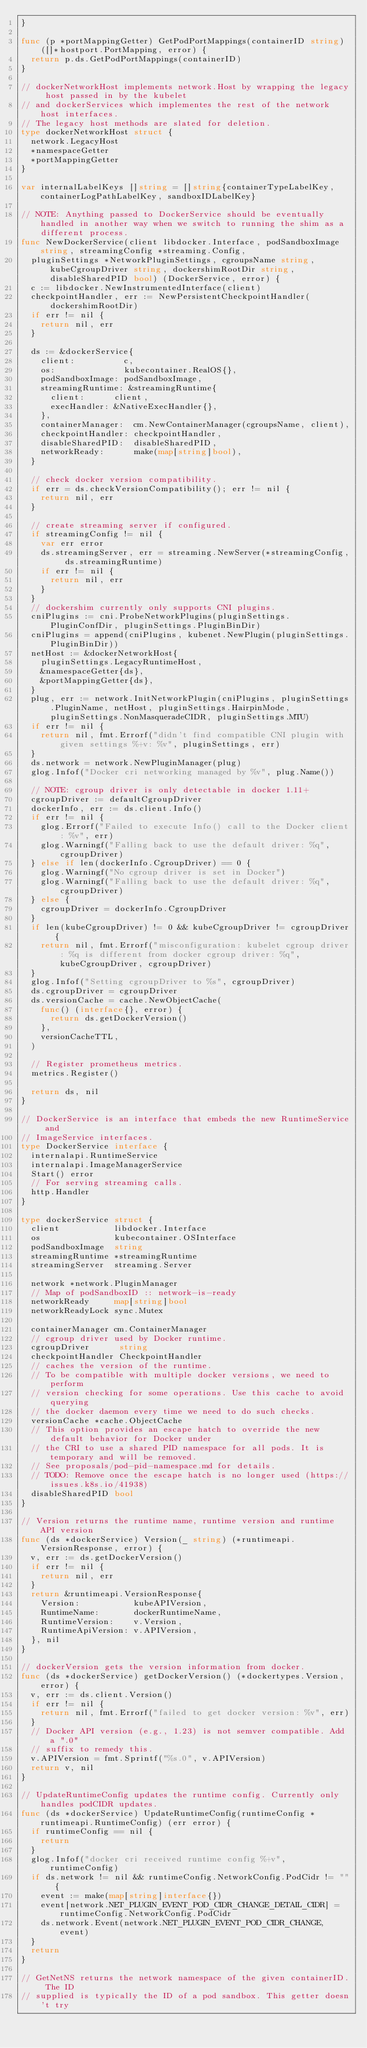Convert code to text. <code><loc_0><loc_0><loc_500><loc_500><_Go_>}

func (p *portMappingGetter) GetPodPortMappings(containerID string) ([]*hostport.PortMapping, error) {
	return p.ds.GetPodPortMappings(containerID)
}

// dockerNetworkHost implements network.Host by wrapping the legacy host passed in by the kubelet
// and dockerServices which implementes the rest of the network host interfaces.
// The legacy host methods are slated for deletion.
type dockerNetworkHost struct {
	network.LegacyHost
	*namespaceGetter
	*portMappingGetter
}

var internalLabelKeys []string = []string{containerTypeLabelKey, containerLogPathLabelKey, sandboxIDLabelKey}

// NOTE: Anything passed to DockerService should be eventually handled in another way when we switch to running the shim as a different process.
func NewDockerService(client libdocker.Interface, podSandboxImage string, streamingConfig *streaming.Config,
	pluginSettings *NetworkPluginSettings, cgroupsName string, kubeCgroupDriver string, dockershimRootDir string, disableSharedPID bool) (DockerService, error) {
	c := libdocker.NewInstrumentedInterface(client)
	checkpointHandler, err := NewPersistentCheckpointHandler(dockershimRootDir)
	if err != nil {
		return nil, err
	}

	ds := &dockerService{
		client:          c,
		os:              kubecontainer.RealOS{},
		podSandboxImage: podSandboxImage,
		streamingRuntime: &streamingRuntime{
			client:      client,
			execHandler: &NativeExecHandler{},
		},
		containerManager:  cm.NewContainerManager(cgroupsName, client),
		checkpointHandler: checkpointHandler,
		disableSharedPID:  disableSharedPID,
		networkReady:      make(map[string]bool),
	}

	// check docker version compatibility.
	if err = ds.checkVersionCompatibility(); err != nil {
		return nil, err
	}

	// create streaming server if configured.
	if streamingConfig != nil {
		var err error
		ds.streamingServer, err = streaming.NewServer(*streamingConfig, ds.streamingRuntime)
		if err != nil {
			return nil, err
		}
	}
	// dockershim currently only supports CNI plugins.
	cniPlugins := cni.ProbeNetworkPlugins(pluginSettings.PluginConfDir, pluginSettings.PluginBinDir)
	cniPlugins = append(cniPlugins, kubenet.NewPlugin(pluginSettings.PluginBinDir))
	netHost := &dockerNetworkHost{
		pluginSettings.LegacyRuntimeHost,
		&namespaceGetter{ds},
		&portMappingGetter{ds},
	}
	plug, err := network.InitNetworkPlugin(cniPlugins, pluginSettings.PluginName, netHost, pluginSettings.HairpinMode, pluginSettings.NonMasqueradeCIDR, pluginSettings.MTU)
	if err != nil {
		return nil, fmt.Errorf("didn't find compatible CNI plugin with given settings %+v: %v", pluginSettings, err)
	}
	ds.network = network.NewPluginManager(plug)
	glog.Infof("Docker cri networking managed by %v", plug.Name())

	// NOTE: cgroup driver is only detectable in docker 1.11+
	cgroupDriver := defaultCgroupDriver
	dockerInfo, err := ds.client.Info()
	if err != nil {
		glog.Errorf("Failed to execute Info() call to the Docker client: %v", err)
		glog.Warningf("Falling back to use the default driver: %q", cgroupDriver)
	} else if len(dockerInfo.CgroupDriver) == 0 {
		glog.Warningf("No cgroup driver is set in Docker")
		glog.Warningf("Falling back to use the default driver: %q", cgroupDriver)
	} else {
		cgroupDriver = dockerInfo.CgroupDriver
	}
	if len(kubeCgroupDriver) != 0 && kubeCgroupDriver != cgroupDriver {
		return nil, fmt.Errorf("misconfiguration: kubelet cgroup driver: %q is different from docker cgroup driver: %q", kubeCgroupDriver, cgroupDriver)
	}
	glog.Infof("Setting cgroupDriver to %s", cgroupDriver)
	ds.cgroupDriver = cgroupDriver
	ds.versionCache = cache.NewObjectCache(
		func() (interface{}, error) {
			return ds.getDockerVersion()
		},
		versionCacheTTL,
	)

	// Register prometheus metrics.
	metrics.Register()

	return ds, nil
}

// DockerService is an interface that embeds the new RuntimeService and
// ImageService interfaces.
type DockerService interface {
	internalapi.RuntimeService
	internalapi.ImageManagerService
	Start() error
	// For serving streaming calls.
	http.Handler
}

type dockerService struct {
	client           libdocker.Interface
	os               kubecontainer.OSInterface
	podSandboxImage  string
	streamingRuntime *streamingRuntime
	streamingServer  streaming.Server

	network *network.PluginManager
	// Map of podSandboxID :: network-is-ready
	networkReady     map[string]bool
	networkReadyLock sync.Mutex

	containerManager cm.ContainerManager
	// cgroup driver used by Docker runtime.
	cgroupDriver      string
	checkpointHandler CheckpointHandler
	// caches the version of the runtime.
	// To be compatible with multiple docker versions, we need to perform
	// version checking for some operations. Use this cache to avoid querying
	// the docker daemon every time we need to do such checks.
	versionCache *cache.ObjectCache
	// This option provides an escape hatch to override the new default behavior for Docker under
	// the CRI to use a shared PID namespace for all pods. It is temporary and will be removed.
	// See proposals/pod-pid-namespace.md for details.
	// TODO: Remove once the escape hatch is no longer used (https://issues.k8s.io/41938)
	disableSharedPID bool
}

// Version returns the runtime name, runtime version and runtime API version
func (ds *dockerService) Version(_ string) (*runtimeapi.VersionResponse, error) {
	v, err := ds.getDockerVersion()
	if err != nil {
		return nil, err
	}
	return &runtimeapi.VersionResponse{
		Version:           kubeAPIVersion,
		RuntimeName:       dockerRuntimeName,
		RuntimeVersion:    v.Version,
		RuntimeApiVersion: v.APIVersion,
	}, nil
}

// dockerVersion gets the version information from docker.
func (ds *dockerService) getDockerVersion() (*dockertypes.Version, error) {
	v, err := ds.client.Version()
	if err != nil {
		return nil, fmt.Errorf("failed to get docker version: %v", err)
	}
	// Docker API version (e.g., 1.23) is not semver compatible. Add a ".0"
	// suffix to remedy this.
	v.APIVersion = fmt.Sprintf("%s.0", v.APIVersion)
	return v, nil
}

// UpdateRuntimeConfig updates the runtime config. Currently only handles podCIDR updates.
func (ds *dockerService) UpdateRuntimeConfig(runtimeConfig *runtimeapi.RuntimeConfig) (err error) {
	if runtimeConfig == nil {
		return
	}
	glog.Infof("docker cri received runtime config %+v", runtimeConfig)
	if ds.network != nil && runtimeConfig.NetworkConfig.PodCidr != "" {
		event := make(map[string]interface{})
		event[network.NET_PLUGIN_EVENT_POD_CIDR_CHANGE_DETAIL_CIDR] = runtimeConfig.NetworkConfig.PodCidr
		ds.network.Event(network.NET_PLUGIN_EVENT_POD_CIDR_CHANGE, event)
	}
	return
}

// GetNetNS returns the network namespace of the given containerID. The ID
// supplied is typically the ID of a pod sandbox. This getter doesn't try</code> 